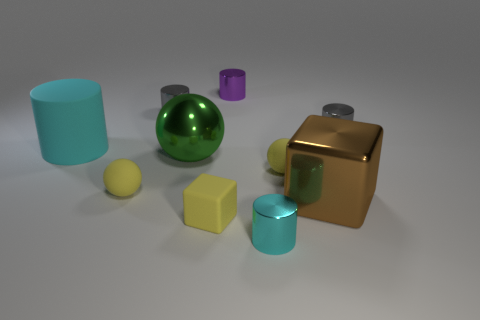Is there any other thing of the same color as the big ball?
Give a very brief answer. No. Are there fewer big brown blocks that are to the left of the yellow block than small gray things right of the tiny cyan metal cylinder?
Make the answer very short. Yes. Is the size of the cyan metal thing the same as the cyan cylinder behind the brown thing?
Provide a succinct answer. No. What number of metal cylinders are the same size as the cyan rubber object?
Offer a terse response. 0. What number of large objects are either yellow rubber spheres or yellow rubber things?
Offer a terse response. 0. Are there any small purple rubber things?
Your response must be concise. No. Are there more gray cylinders that are on the left side of the tiny cube than tiny purple shiny cylinders behind the big brown metallic object?
Provide a succinct answer. No. What color is the tiny metallic object that is in front of the cylinder on the right side of the tiny cyan metal object?
Keep it short and to the point. Cyan. Are there any large metallic objects of the same color as the rubber cylinder?
Offer a very short reply. No. What size is the gray cylinder left of the gray cylinder that is to the right of the cyan cylinder to the right of the matte cylinder?
Your response must be concise. Small. 